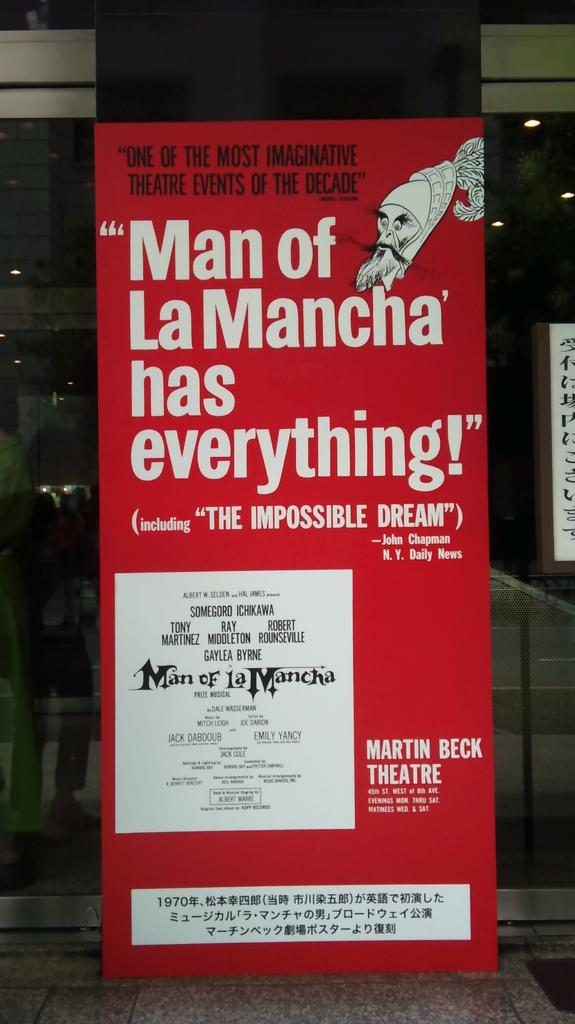<image>
Describe the image concisely. Poster advertising "Man of La Macha" at the Martin Beck Theatre. 